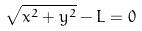<formula> <loc_0><loc_0><loc_500><loc_500>\sqrt { x ^ { 2 } + y ^ { 2 } } - L = 0</formula> 